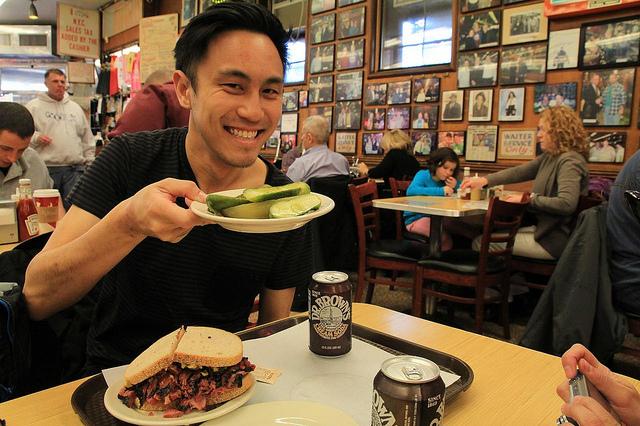Who is wearing a bright blue shirt?
Be succinct. Girl. How many pictures on the wall?
Quick response, please. Lot. Is the man smiling?
Give a very brief answer. Yes. 